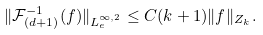Convert formula to latex. <formula><loc_0><loc_0><loc_500><loc_500>\| \mathcal { F } _ { ( d + 1 ) } ^ { - 1 } ( f ) \| _ { L ^ { \infty , 2 } _ { e } } \leq C ( k + 1 ) \| f \| _ { Z _ { k } } .</formula> 